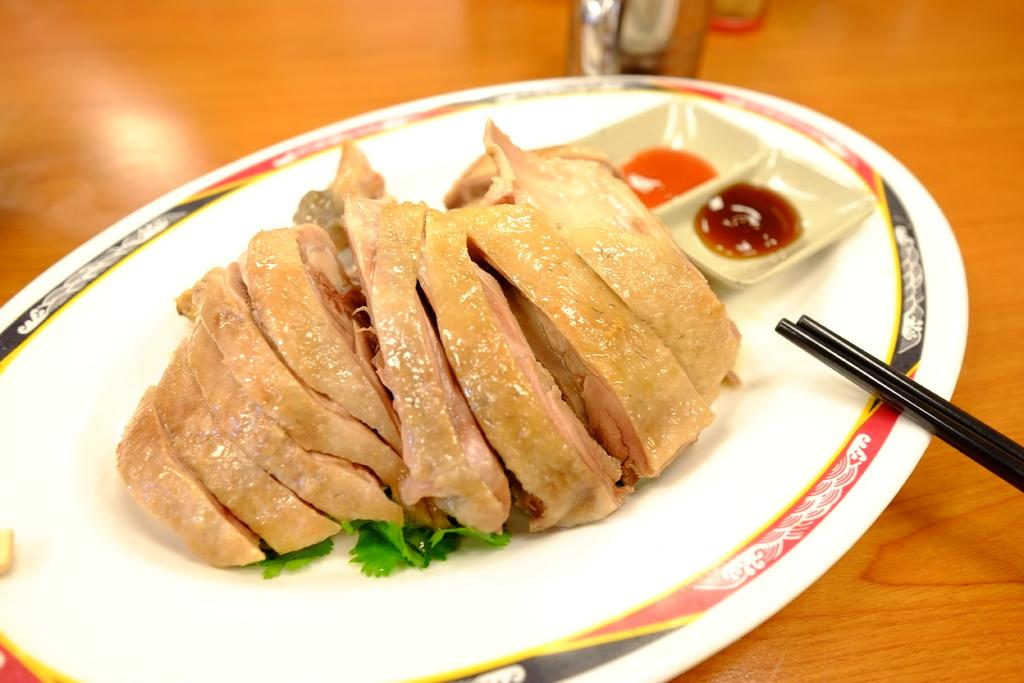What type of food is on the plate in the image? There is a plate full of meat in the image. Are there any additional items on the plate besides the meat? Yes, there are sauces on the plate. What utensil is visible in the image? Chopsticks are visible in the image. Where is the plate placed in the image? The plate is placed on a table. What type of watch is the father wearing in the image? There is no father or watch present in the image. 